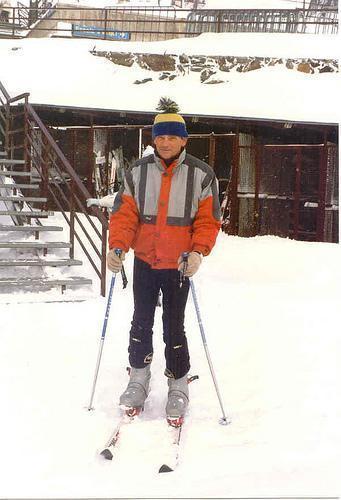How many skiers?
Give a very brief answer. 1. 